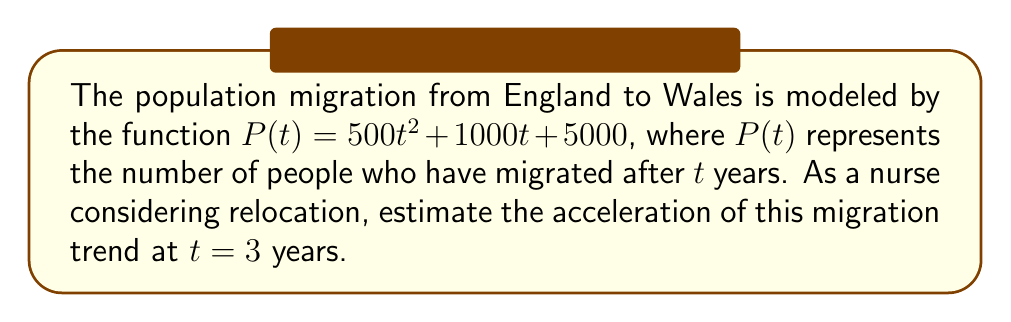Help me with this question. To find the acceleration of the population migration trend, we need to calculate the second derivative of the given function $P(t)$.

Step 1: Find the first derivative (velocity of migration)
$$\frac{dP}{dt} = P'(t) = 1000t + 1000$$

Step 2: Find the second derivative (acceleration of migration)
$$\frac{d^2P}{dt^2} = P''(t) = 1000$$

Step 3: Evaluate the acceleration at $t = 3$
Since the second derivative is a constant, the acceleration is the same at all times, including $t = 3$.

$$P''(3) = 1000$$

Therefore, the acceleration of the population migration trend is 1000 people per year squared.
Answer: 1000 people/year² 